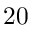<formula> <loc_0><loc_0><loc_500><loc_500>2 0</formula> 